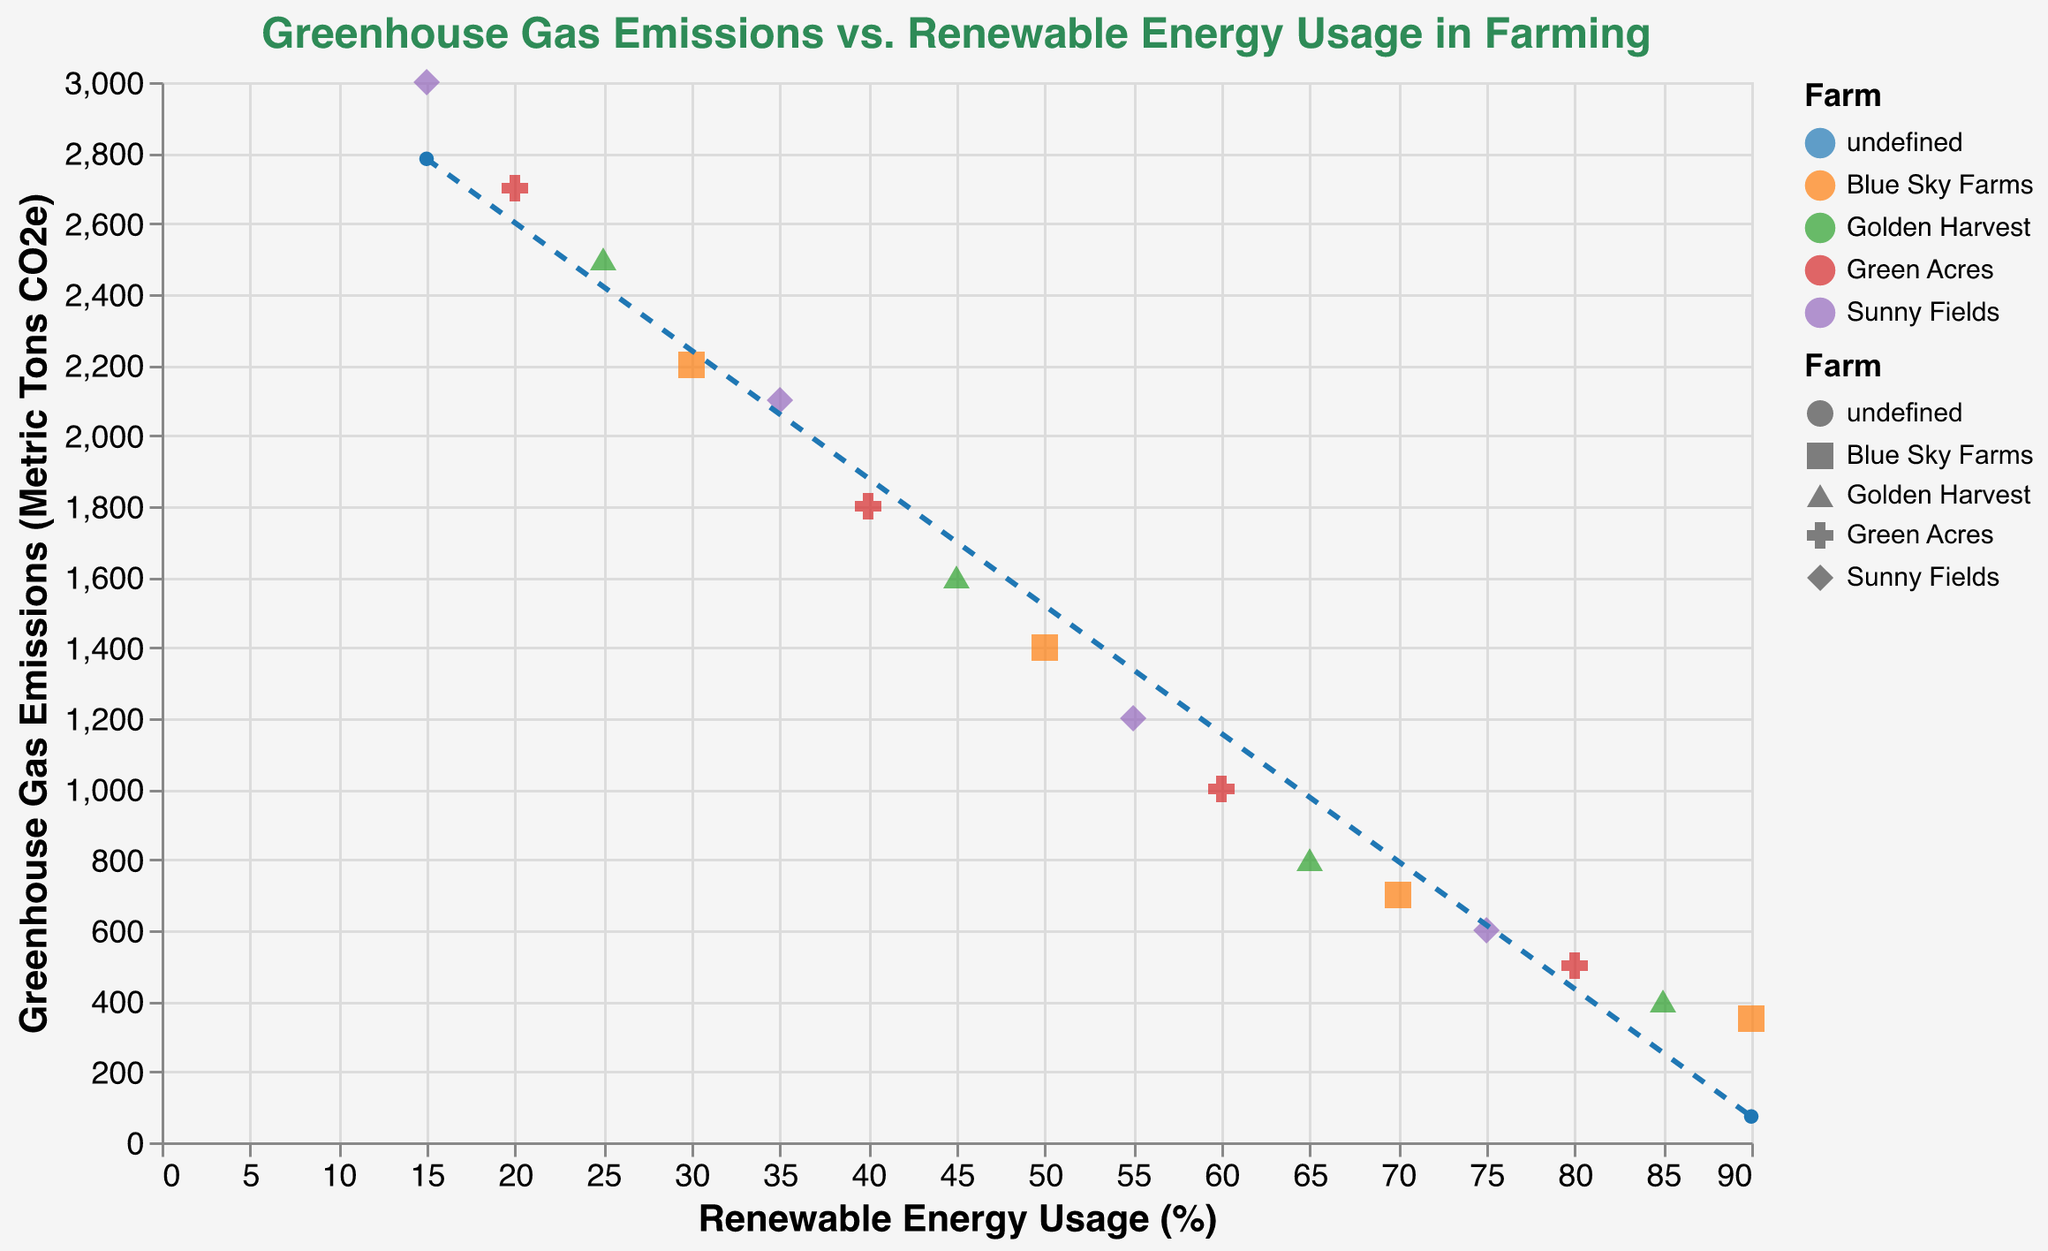What is the title of the figure? The title is located at the top of the figure and reads "Greenhouse Gas Emissions vs. Renewable Energy Usage in Farming."
Answer: Greenhouse Gas Emissions vs. Renewable Energy Usage in Farming How many different farms are represented in the figure? There are four different colors and shapes each representing a unique farm, which can be observed in the legend.
Answer: 4 Which farm shows the highest renewable energy usage in 2022? Look for the point with the highest value on the x-axis for the year 2022 in the tooltip; it's "Blue Sky Farms" with 90%.
Answer: Blue Sky Farms What is the relationship between renewable energy usage and greenhouse gas emissions as shown by the trend line? The trend line, which is a dashed red line, slopes downward indicating that as renewable energy usage increases, greenhouse gas emissions decrease.
Answer: Decreasing relationship What are the emissions for Sunny Fields when the renewable energy usage is 55%? Locate the point for "Sunny Fields" at 55% on the x-axis and read the corresponding y-axis value or use the tooltip; the emission is 1200 metric tons of CO2e.
Answer: 1200 metric tons CO2e Which farm reduced its greenhouse gas emissions the most from 2015 to 2022? Compare the y-axis values for each farm between 2015 and 2022 and calculate the difference; Blue Sky Farms had emissions of 2200 in 2016 and 350 in 2022, a reduction of 1850.
Answer: Blue Sky Farms By how much did total greenhouse gas emissions decrease from the highest to the lowest renewable energy usage among all data points? Identify the maximum and minimum values on the x-axis; the highest renewable energy usage is 90% (350 tons) and the lowest is 15% (3000 tons), the difference is 3000 - 350 = 2650.
Answer: 2650 metric tons CO2e What is the average renewable energy usage among all farms in 2021? Calculate the average of renewable energy usage values for the year 2021: (75+80)/2.
Answer: (75+80)/2 = 77.5 Which year shows the highest variance in greenhouse gas emissions among the four farms? Check the variance in y-axis values for all farms per year; in 2015, emissions range from 2700 to 3000 indicating a higher variance than other years.
Answer: 2015 What is the slope of the trend line? The slope can be interpreted from the downward trend of the line with the relationship that greenhouse gas emissions decrease as renewable energy usage increases, which can usually be found in detailed statistics or trend line parameters.
Answer: Slope is negative 